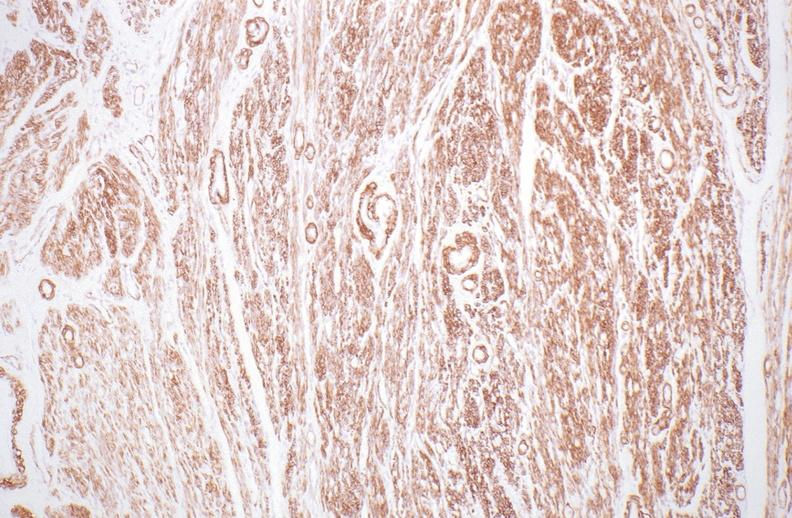do alpha smooth muscle actin immunohistochemical stain?
Answer the question using a single word or phrase. Yes 